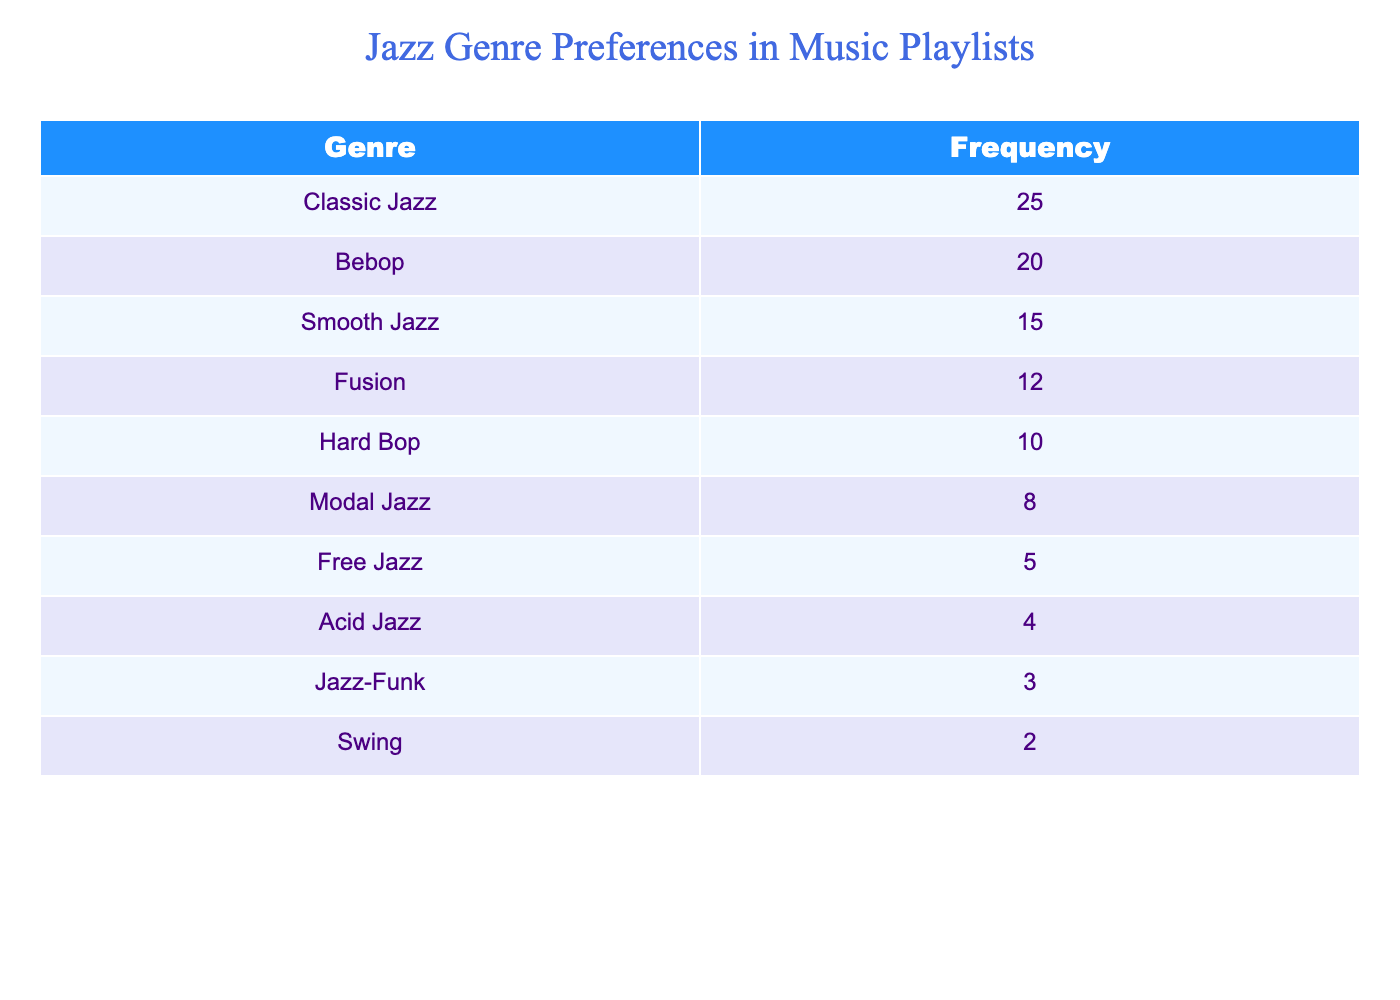What is the frequency of Smooth Jazz in the music playlists? The frequency of Smooth Jazz is directly listed in the table under the genre Smooth Jazz, which shows a value of 15.
Answer: 15 Which jazz genre has the highest frequency? The genre with the highest frequency is Classic Jazz, as it has the highest value of 25 listed in the table.
Answer: Classic Jazz How many genres have a frequency of less than 10? By examining the table, we see the genres with frequencies below 10: Modal Jazz (8), Free Jazz (5), Acid Jazz (4), and Jazz-Funk (3). This totals four genres.
Answer: 4 What is the total frequency of all jazz genres listed in the table? To find the total frequency, we sum all the listed frequencies: 25 + 20 + 15 + 12 + 10 + 8 + 5 + 4 + 3 + 2 = 109. Therefore, the total frequency is 109.
Answer: 109 Is Jazz-Funk the least preferred genre in the playlists? Jazz-Funk has a frequency of 3, which is lower than all other genres listed in the table, confirming that it is indeed the least preferred genre.
Answer: Yes What is the difference in frequency between Classic Jazz and Bebop? The frequency of Classic Jazz is 25 and the frequency of Bebop is 20. The difference is calculated as 25 - 20 = 5.
Answer: 5 If we consider only genres with frequencies above 10, how many genres are there and what are their names? The genres with frequencies above 10 are Classic Jazz (25), Bebop (20), and Smooth Jazz (15). Counting these, we have three genres: Classic Jazz, Bebop, and Smooth Jazz.
Answer: 3; Classic Jazz, Bebop, Smooth Jazz What percentage of the total frequency is represented by Hard Bop? The frequency for Hard Bop is 10. First calculate the total frequency which is 109. Then, (10 / 109) * 100 gives approximately 9.17%.
Answer: Approximately 9.17% How many genres have a frequency greater than 7 and how many of those genres are classified as traditional jazz? The genres with frequencies greater than 7 are Classic Jazz (25), Bebop (20), Smooth Jazz (15), Fusion (12), and Hard Bop (10)—totaling five genres. Among these, Classic Jazz, Bebop, Smooth Jazz, and Hard Bop are considered traditional jazz styles (4).
Answer: 5 genres; 4 traditional jazz styles 